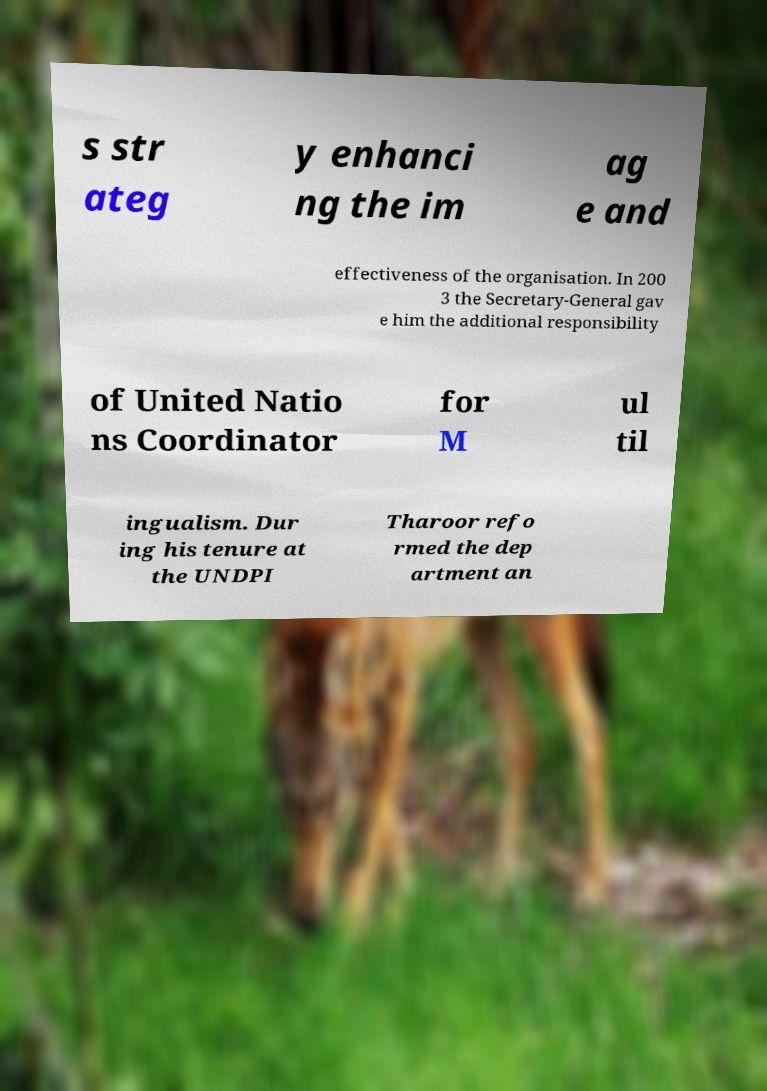Please read and relay the text visible in this image. What does it say? s str ateg y enhanci ng the im ag e and effectiveness of the organisation. In 200 3 the Secretary-General gav e him the additional responsibility of United Natio ns Coordinator for M ul til ingualism. Dur ing his tenure at the UNDPI Tharoor refo rmed the dep artment an 